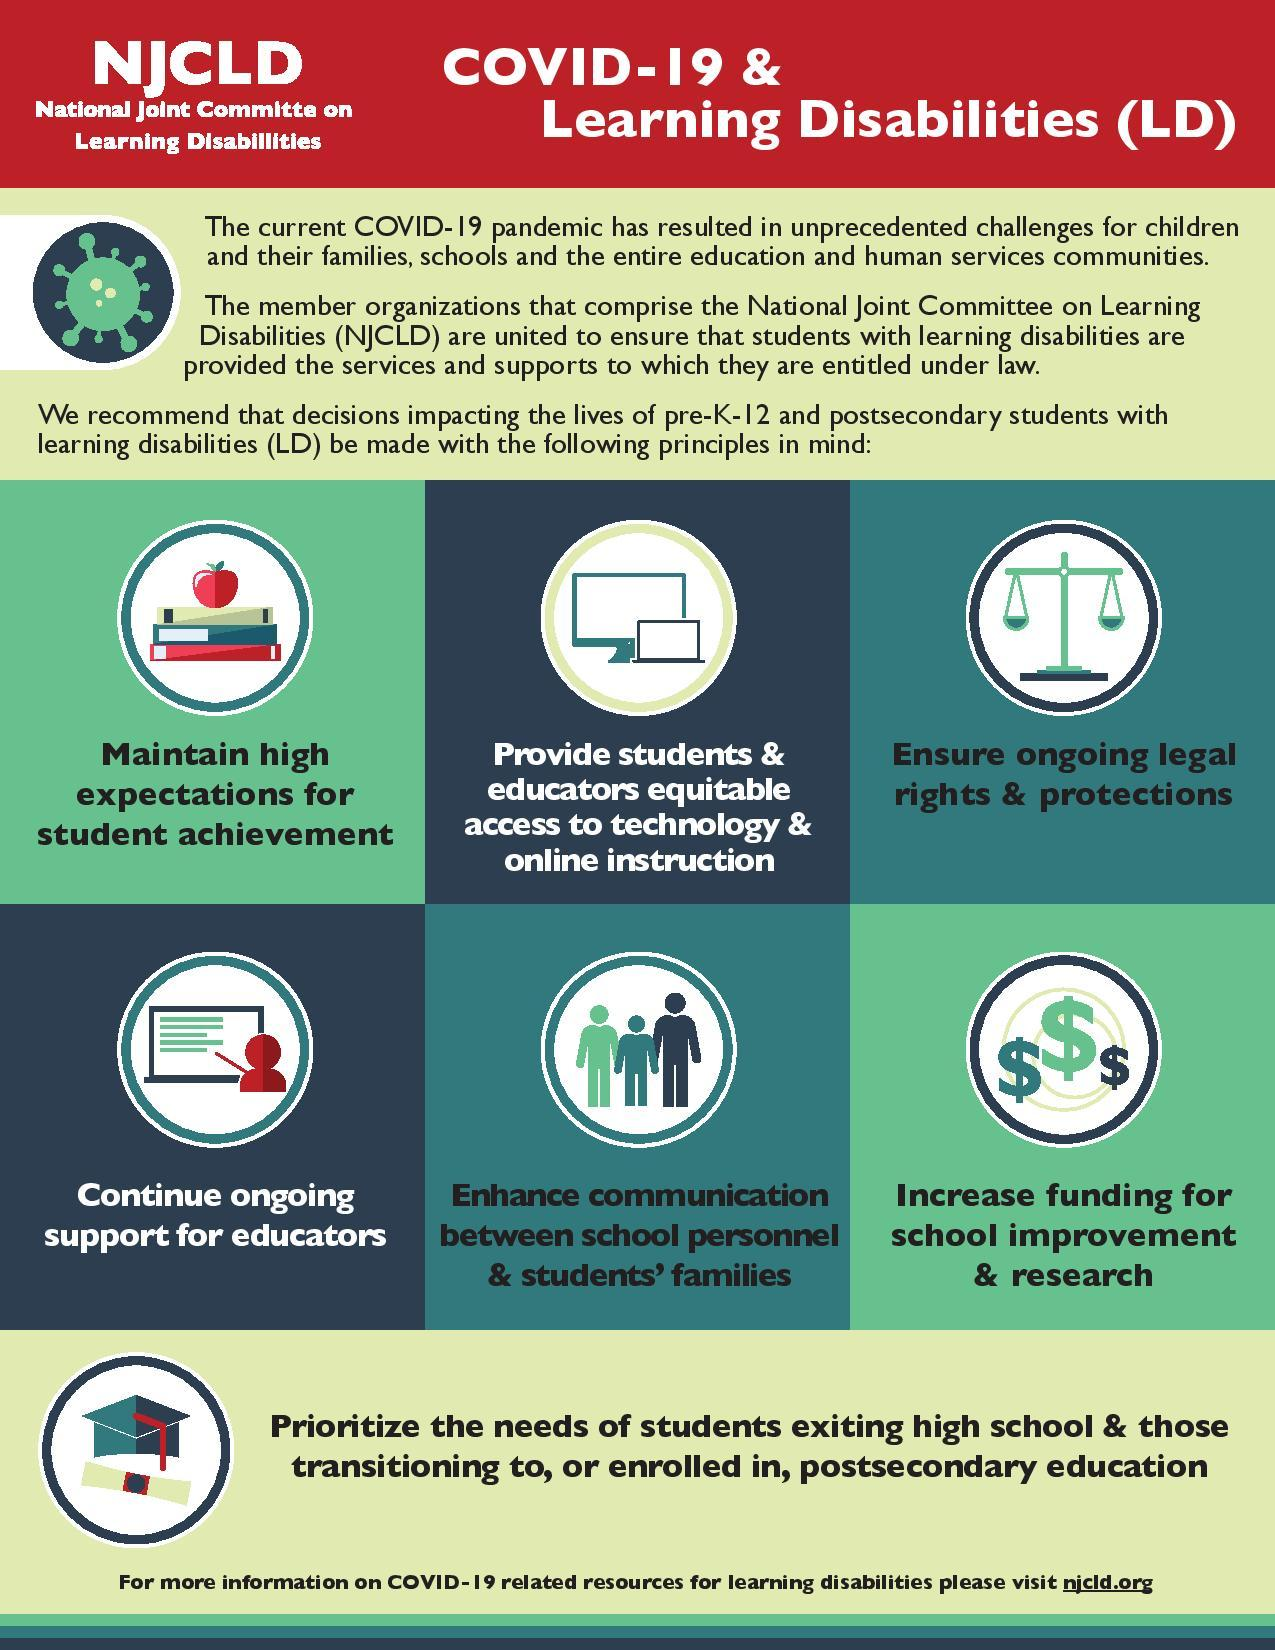Specify some key components in this picture. The fourth principle in the infographic is continuous support for educators. The third principle in the infographic is to ensure ongoing legal rights and protections. The fifth principle in the infographic is "Enhance communication between school personnel and students' families. The sixth principle in the infographic is increasing funding for school improvement and research. The number of principles depicted in this infographic is six. 